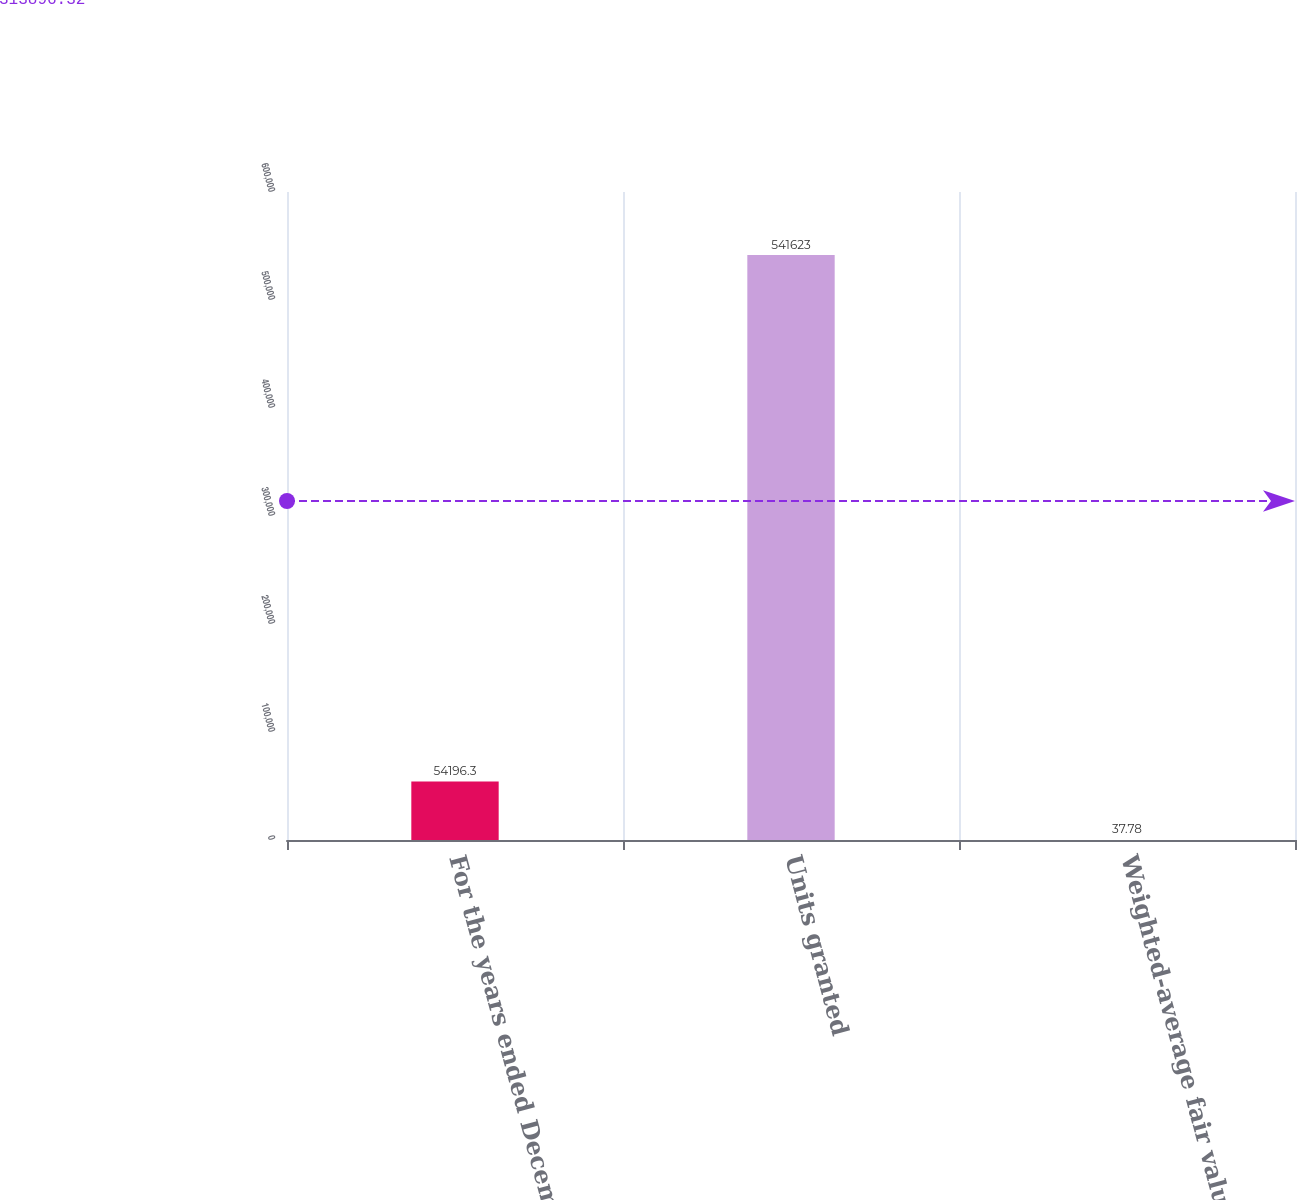Convert chart. <chart><loc_0><loc_0><loc_500><loc_500><bar_chart><fcel>For the years ended December<fcel>Units granted<fcel>Weighted-average fair value at<nl><fcel>54196.3<fcel>541623<fcel>37.78<nl></chart> 